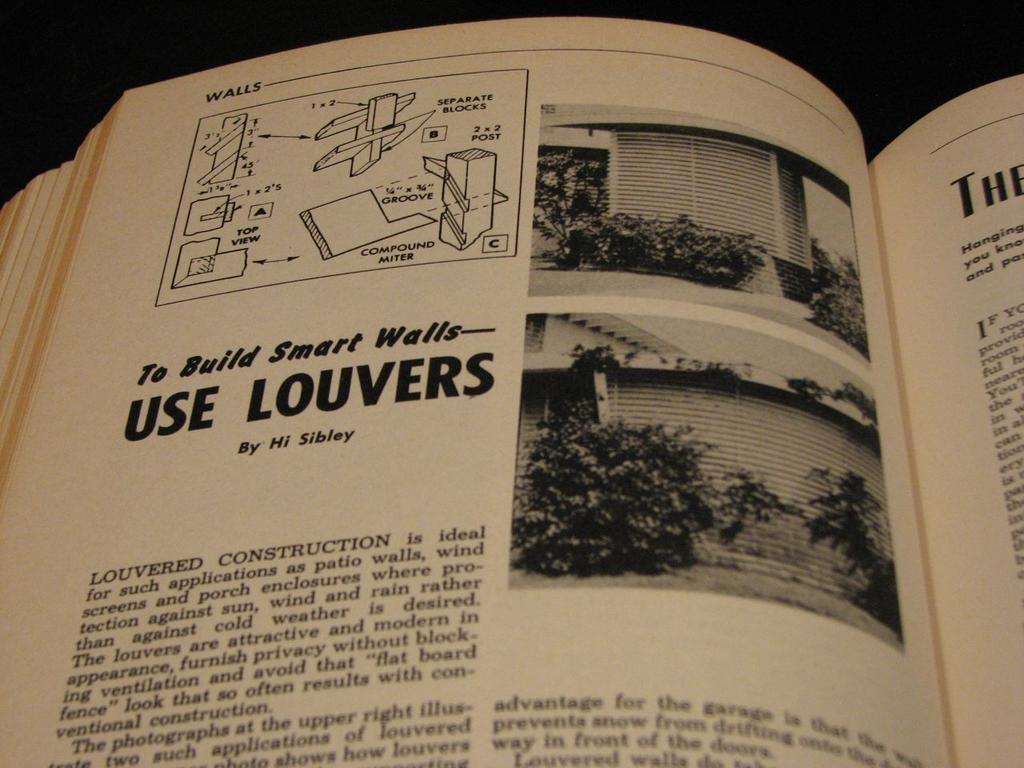<image>
Summarize the visual content of the image. A home improvement book is open to a chapter about using louvers. 